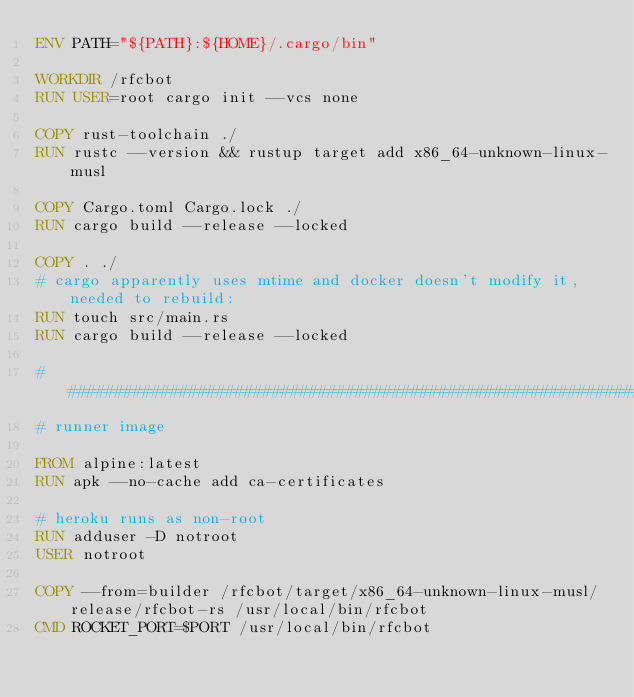<code> <loc_0><loc_0><loc_500><loc_500><_Dockerfile_>ENV PATH="${PATH}:${HOME}/.cargo/bin"

WORKDIR /rfcbot
RUN USER=root cargo init --vcs none

COPY rust-toolchain ./
RUN rustc --version && rustup target add x86_64-unknown-linux-musl

COPY Cargo.toml Cargo.lock ./
RUN cargo build --release --locked

COPY . ./
# cargo apparently uses mtime and docker doesn't modify it, needed to rebuild:
RUN touch src/main.rs
RUN cargo build --release --locked

###############################################################################
# runner image

FROM alpine:latest
RUN apk --no-cache add ca-certificates

# heroku runs as non-root
RUN adduser -D notroot
USER notroot

COPY --from=builder /rfcbot/target/x86_64-unknown-linux-musl/release/rfcbot-rs /usr/local/bin/rfcbot
CMD ROCKET_PORT=$PORT /usr/local/bin/rfcbot
</code> 